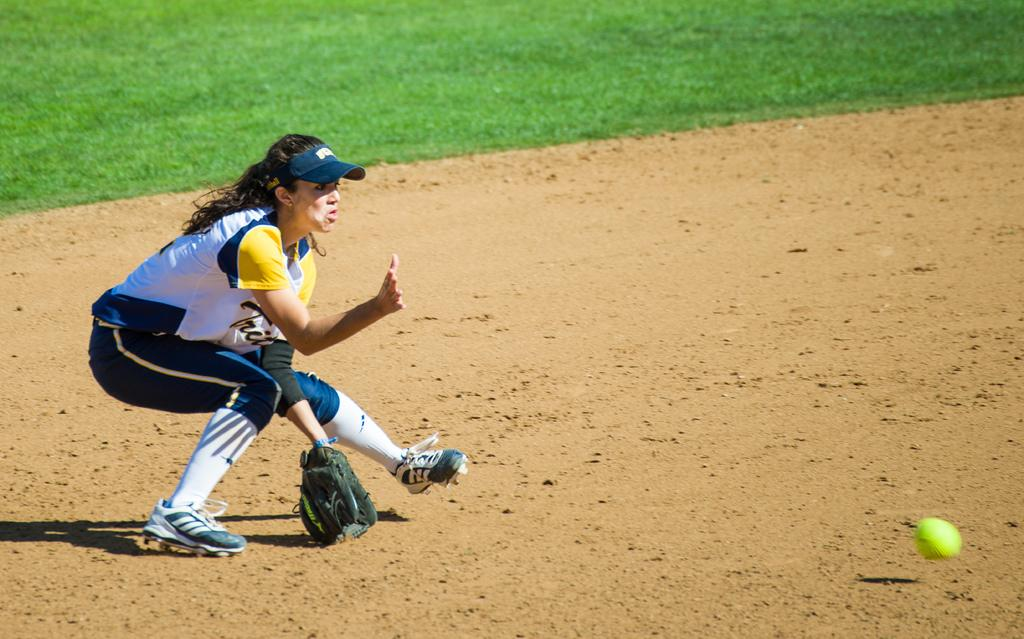What is the main subject of the image? There is a person standing on the ground in the image. What object can be seen on the right side of the image? There is a ball on the right side of the image. What type of natural environment is visible in the background of the image? There is grass visible in the background of the image. What type of gun is being used by the person in the image? There is no gun present in the image; the person is simply standing on the ground. What is being served for dinner in the image? There is no dinner or food visible in the image. 